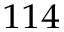<formula> <loc_0><loc_0><loc_500><loc_500>^ { 1 1 4 }</formula> 